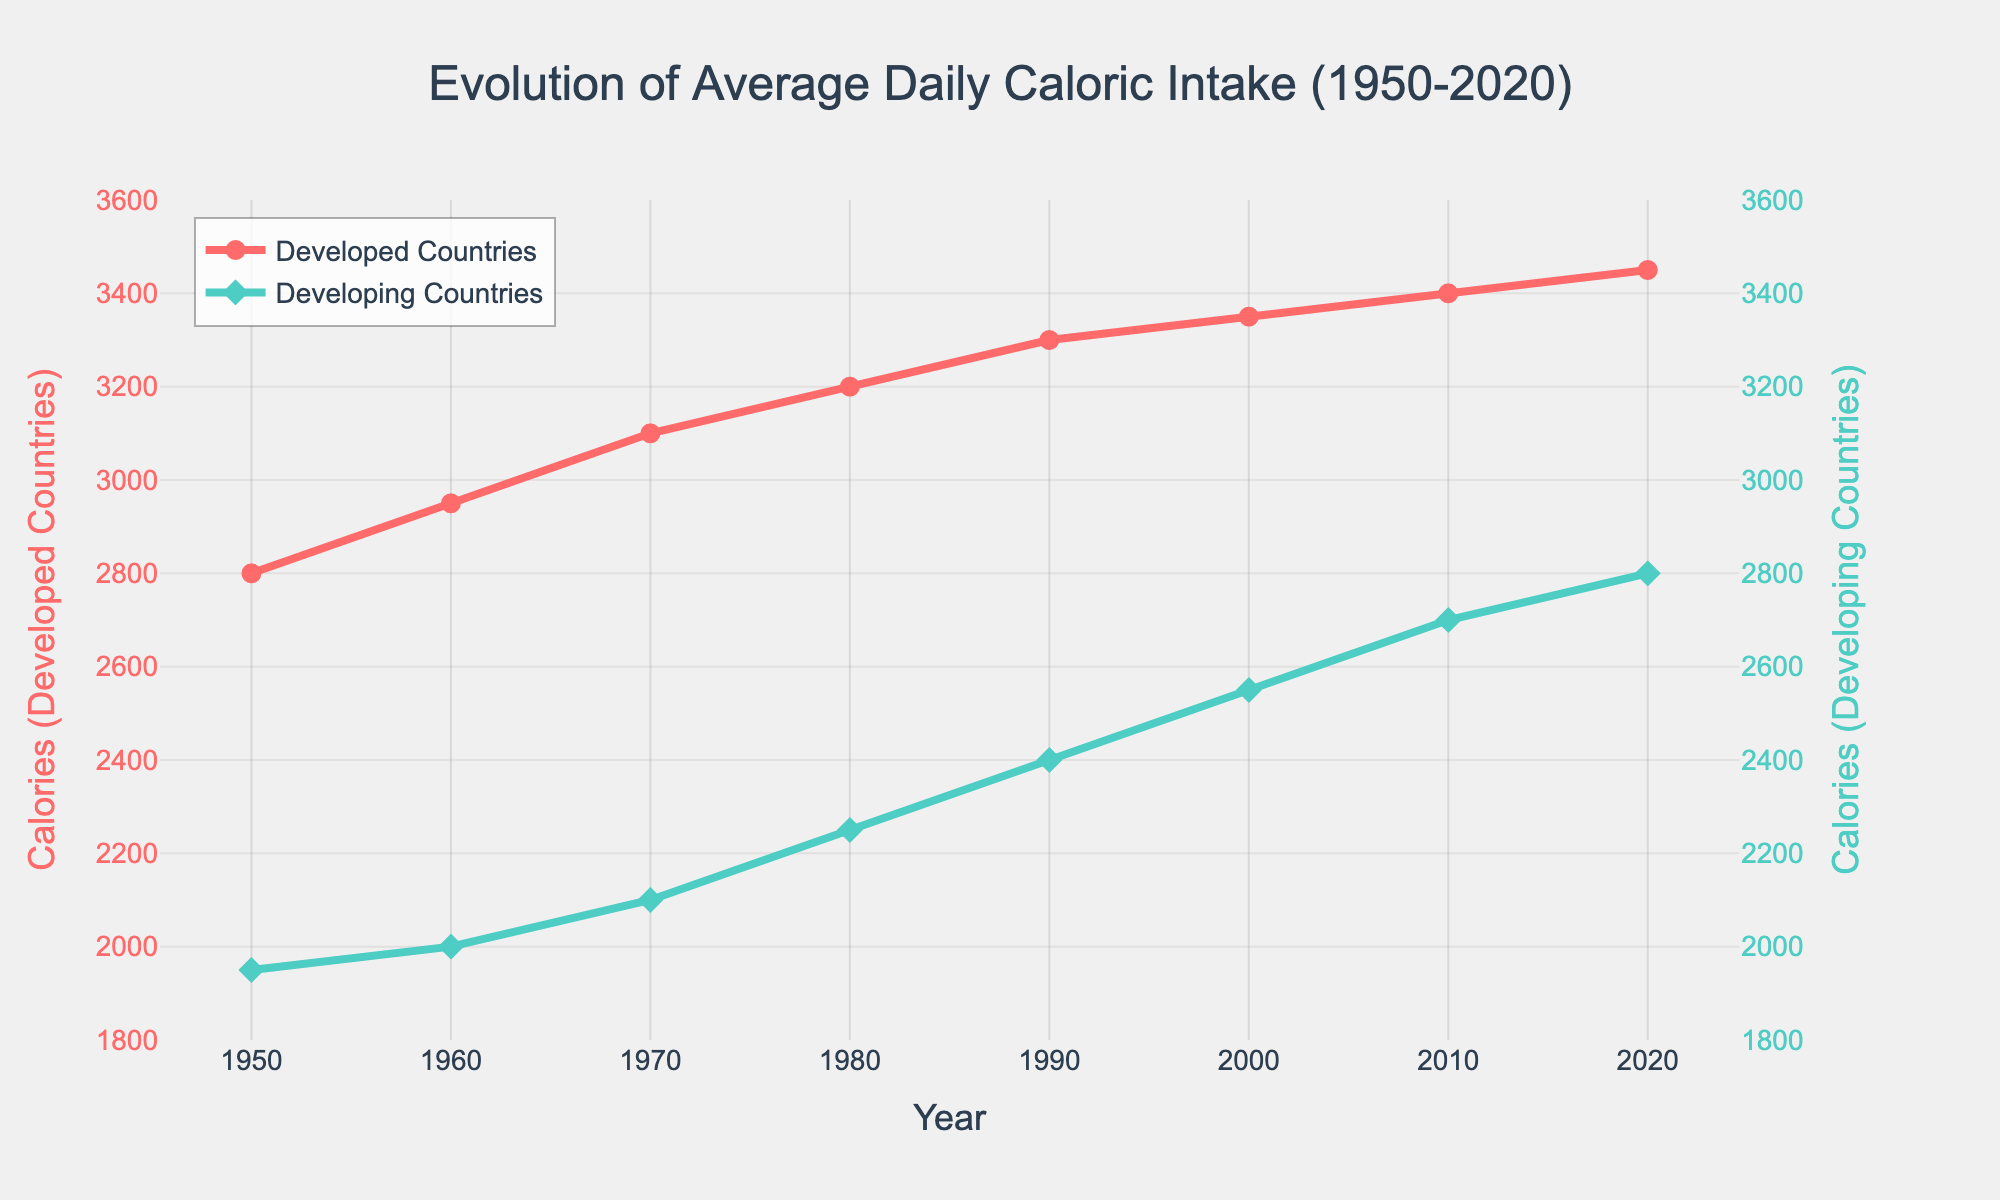What is the average caloric intake for Developed Countries in 2020? To find the average caloric intake for Developed Countries in 2020, simply refer to the data point at the year 2020 along the "Developed Countries" line, which is 3450 calories.
Answer: 3450 How much did the caloric intake in Developing Countries increase from 1950 to 2020? Subtract the caloric intake in 1950 from the caloric intake in 2020 for Developing Countries: 2800 (2020) - 1950 (1950) = 850 calories.
Answer: 850 In what decade did the Developed Countries see the largest increase in caloric intake? By inspecting the slopes of the lines, the largest increase happened between 1950-1960, where the caloric intake increased from 2800 to 2950, a difference of 150 calories.
Answer: 1950-1960 Which year shows the smallest difference in caloric intake between Developed and Developing Countries? Calculate the differences for each year and find the smallest: 850 (1950), 950 (1960), 1000 (1970), 950 (1980), 900 (1990), 800 (2000), 700 (2010), 650 (2020). The smallest difference is 650 calories in 2020.
Answer: 2020 What is the trend in caloric intake for Developing Countries since 1950? Examine the "Developing Countries" line which shows a clear upward trend from 1950 to 2020, indicating an overall increase in caloric intake.
Answer: Increasing By how much did the gap between Developed and Developing Countries' caloric intake decrease from 1990 to 2020? Calculate the difference in gaps: Difference in 1990 (3300-2400=900 calories) and in 2020 (3450-2800=650 calories), then subtract 900-650 = 250 calories.
Answer: 250 Compare the caloric intake in 1980 between Developed and Developing Countries. Which one is higher and by how much? The caloric intake for Developed Countries in 1980 is 3200, and for Developing Countries, it is 2250. The difference is 3200 - 2250 = 950 calories, so Developed Countries have a higher intake by 950 calories.
Answer: Developed Countries by 950 How did the caloric intake in Developing Countries change from 1970 to 2000? Subtract the caloric intake in 1970 from 2000 for Developing Countries: 2550 (2000) - 2100 (1970) = 450 calories. This indicates an increase of 450 calories over 30 years.
Answer: Increased by 450 What is the visual difference between the markers used for Developed and Developing Countries? The markers for Developed Countries are circles, colored in red, and the markers for Developing Countries are diamonds, colored in green.
Answer: Circles (red) for Developed, Diamonds (green) for Developing 